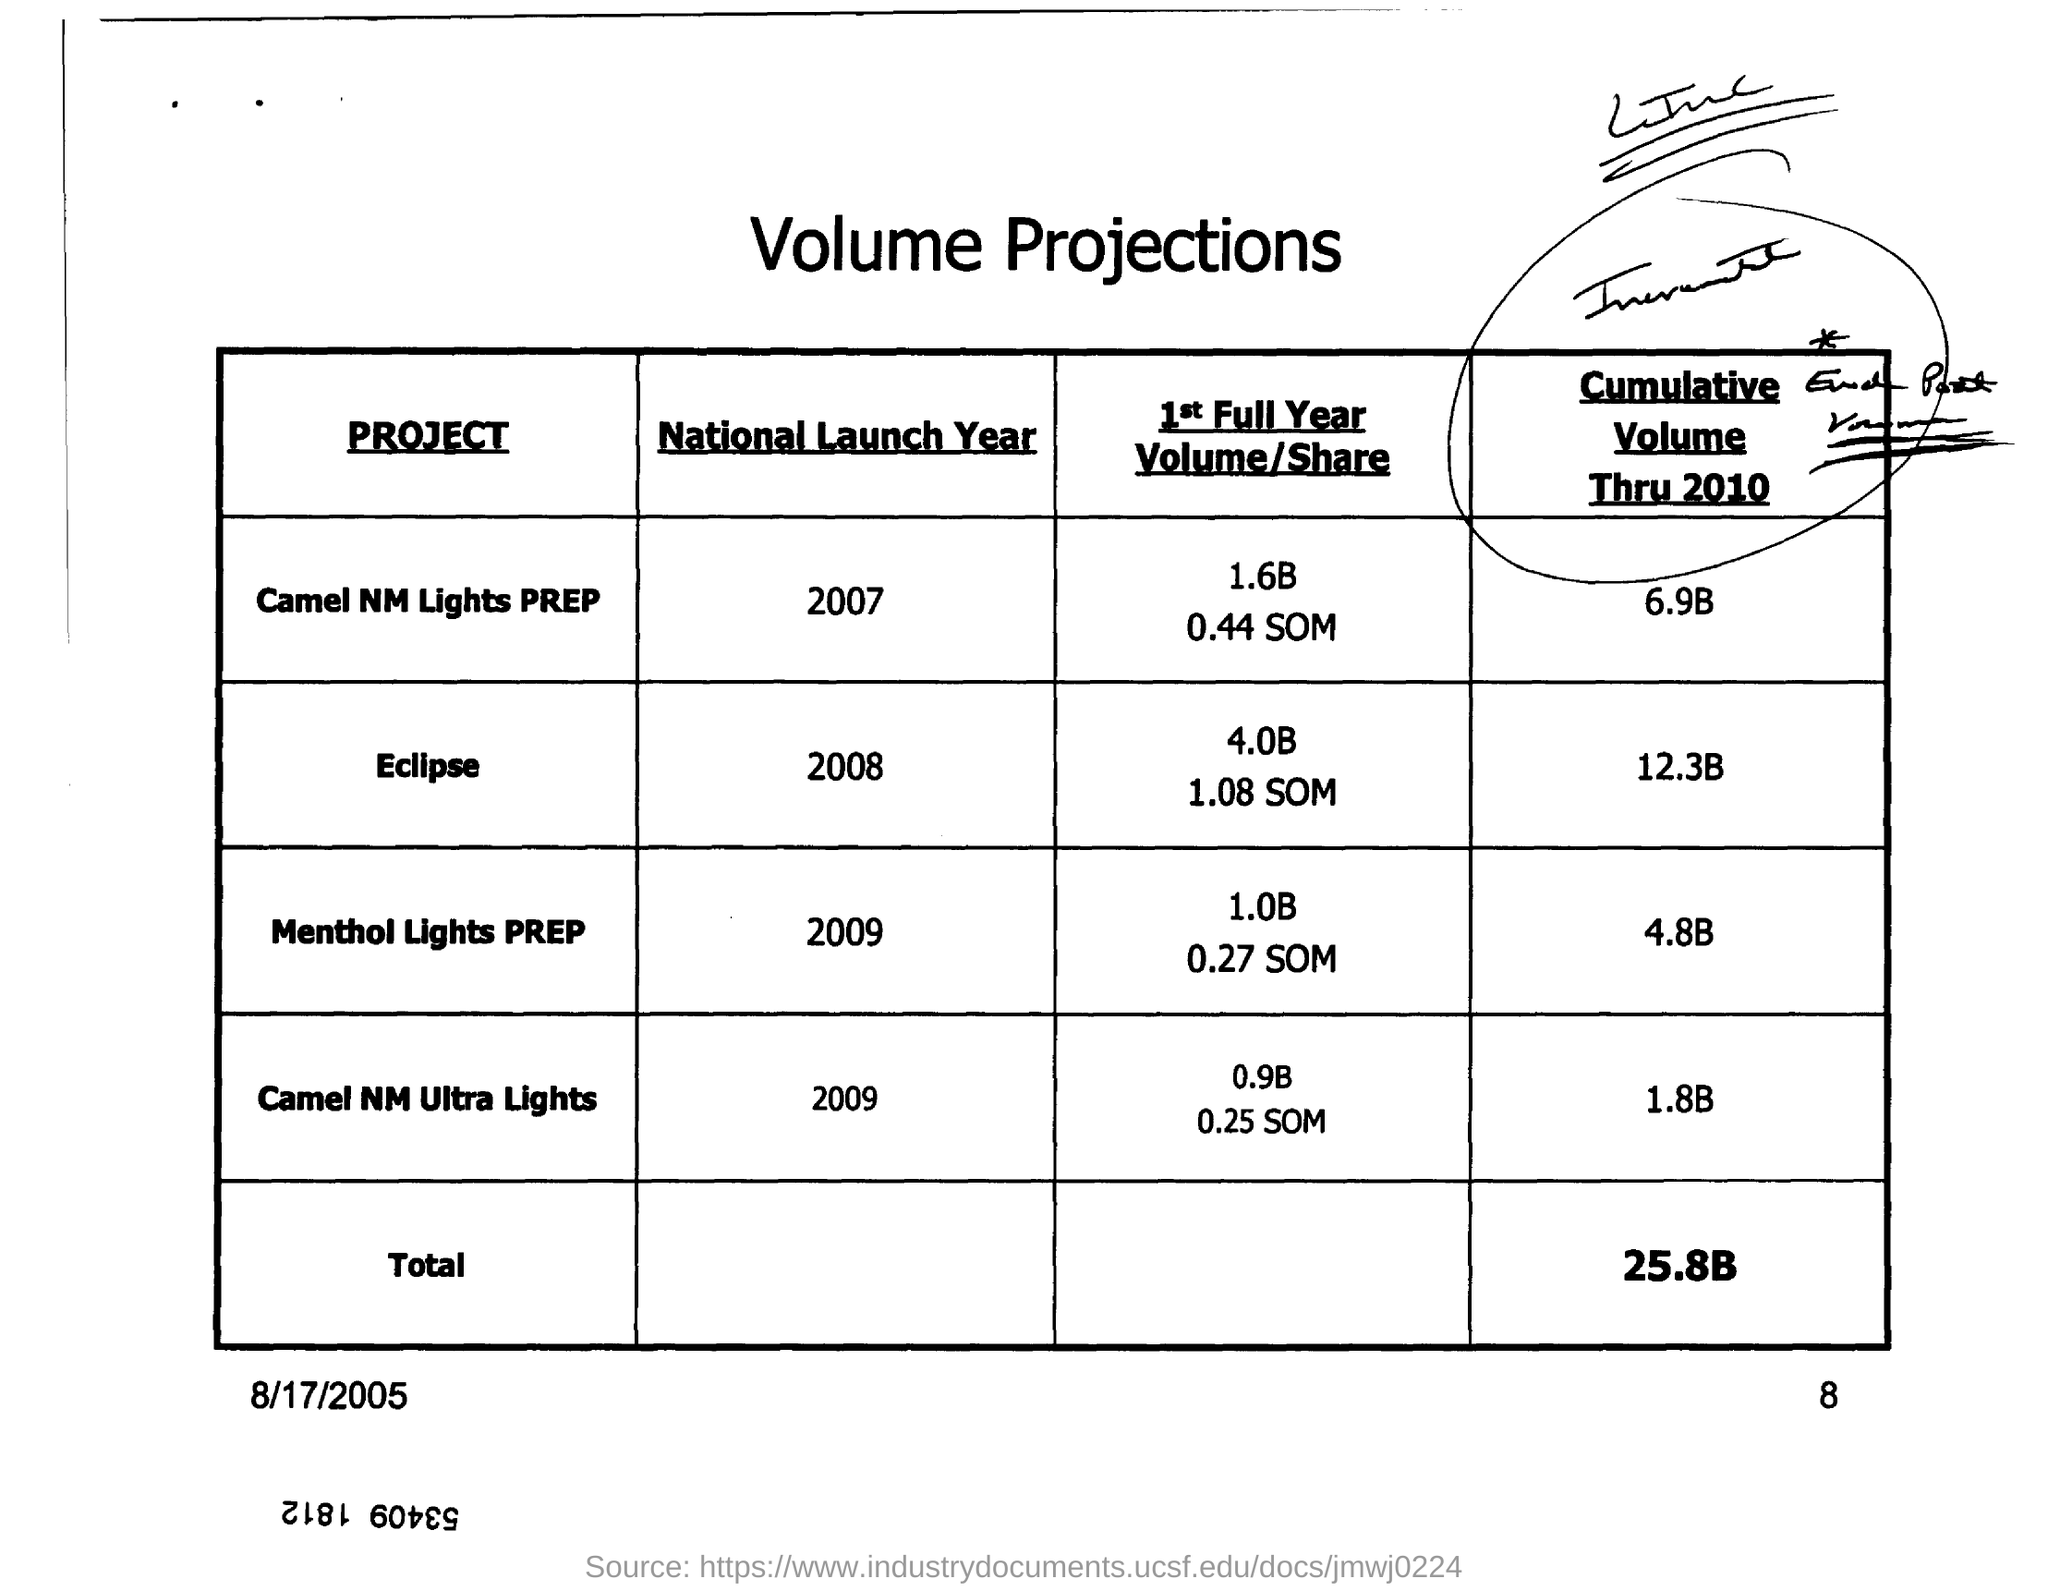Indicate a few pertinent items in this graphic. The cumulative volume for Camel NM Ultra Lights as of 2010 was 1.8 billion shares. The "National Launch Year" for "Camel NM Ultra Lights" was 2009. The total for cumulative volume through 2010 is 25.8 billion. The National Launch Year for Eclipse was 2008. 